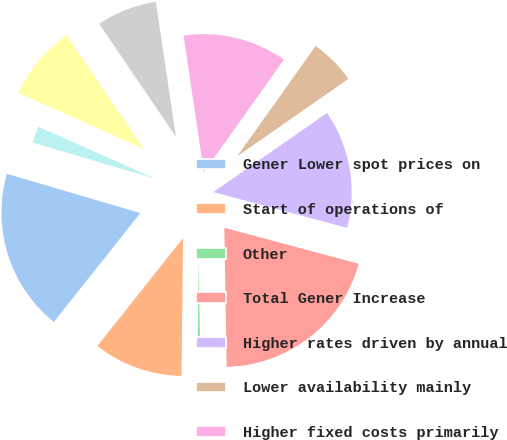Convert chart to OTSL. <chart><loc_0><loc_0><loc_500><loc_500><pie_chart><fcel>Gener Lower spot prices on<fcel>Start of operations of<fcel>Other<fcel>Total Gener Increase<fcel>Higher rates driven by annual<fcel>Lower availability mainly<fcel>Higher fixed costs primarily<fcel>Unfavorable FX remeasurement<fcel>Total Argentina Decrease<fcel>Higher volume of energy sales<nl><fcel>18.88%<fcel>10.5%<fcel>0.45%<fcel>20.56%<fcel>13.85%<fcel>5.48%<fcel>12.18%<fcel>7.15%<fcel>8.83%<fcel>2.12%<nl></chart> 